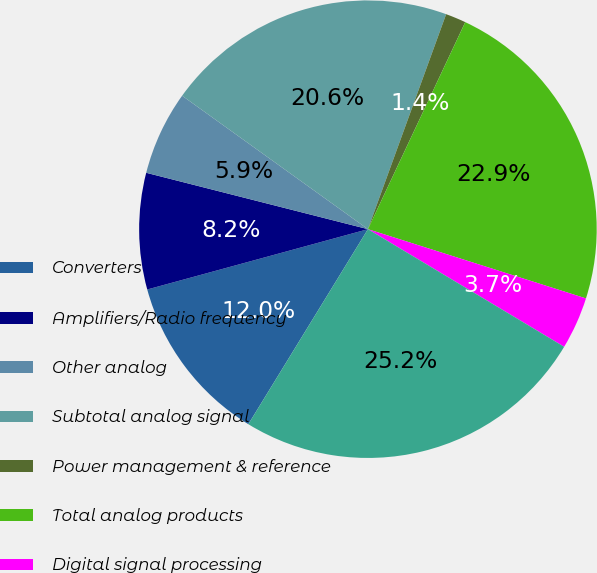Convert chart to OTSL. <chart><loc_0><loc_0><loc_500><loc_500><pie_chart><fcel>Converters<fcel>Amplifiers/Radio frequency<fcel>Other analog<fcel>Subtotal analog signal<fcel>Power management & reference<fcel>Total analog products<fcel>Digital signal processing<fcel>Total Revenue<nl><fcel>12.0%<fcel>8.21%<fcel>5.95%<fcel>20.64%<fcel>1.44%<fcel>22.9%<fcel>3.7%<fcel>25.16%<nl></chart> 